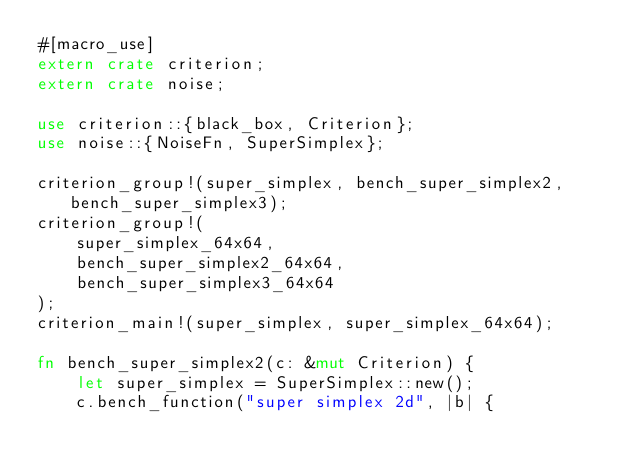<code> <loc_0><loc_0><loc_500><loc_500><_Rust_>#[macro_use]
extern crate criterion;
extern crate noise;

use criterion::{black_box, Criterion};
use noise::{NoiseFn, SuperSimplex};

criterion_group!(super_simplex, bench_super_simplex2, bench_super_simplex3);
criterion_group!(
    super_simplex_64x64,
    bench_super_simplex2_64x64,
    bench_super_simplex3_64x64
);
criterion_main!(super_simplex, super_simplex_64x64);

fn bench_super_simplex2(c: &mut Criterion) {
    let super_simplex = SuperSimplex::new();
    c.bench_function("super simplex 2d", |b| {</code> 